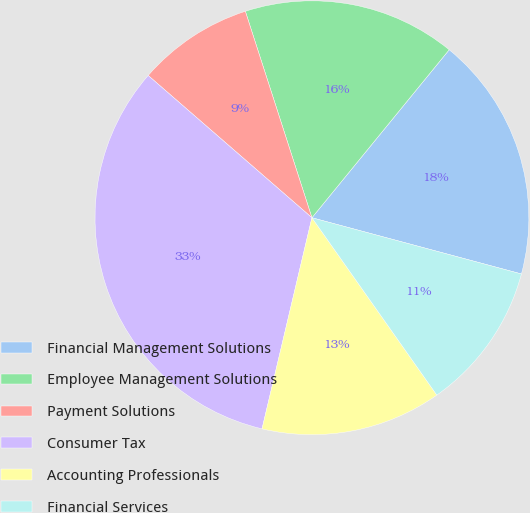Convert chart to OTSL. <chart><loc_0><loc_0><loc_500><loc_500><pie_chart><fcel>Financial Management Solutions<fcel>Employee Management Solutions<fcel>Payment Solutions<fcel>Consumer Tax<fcel>Accounting Professionals<fcel>Financial Services<nl><fcel>18.27%<fcel>15.87%<fcel>8.65%<fcel>32.69%<fcel>13.46%<fcel>11.06%<nl></chart> 